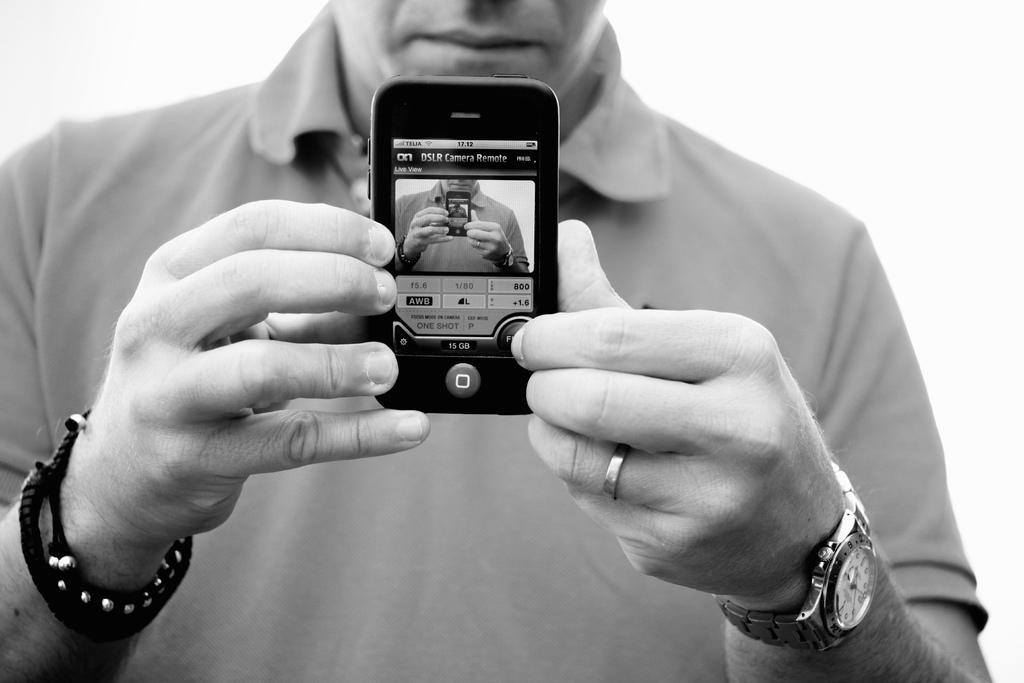What is the person in the image holding? The person is holding a mobile. What can be seen in the background of the image? The background is white. How many cattle are present in the image? There are no cattle present in the image. What is the person's hope for the future in the image? The image does not provide any information about the person's hopes for the future. 